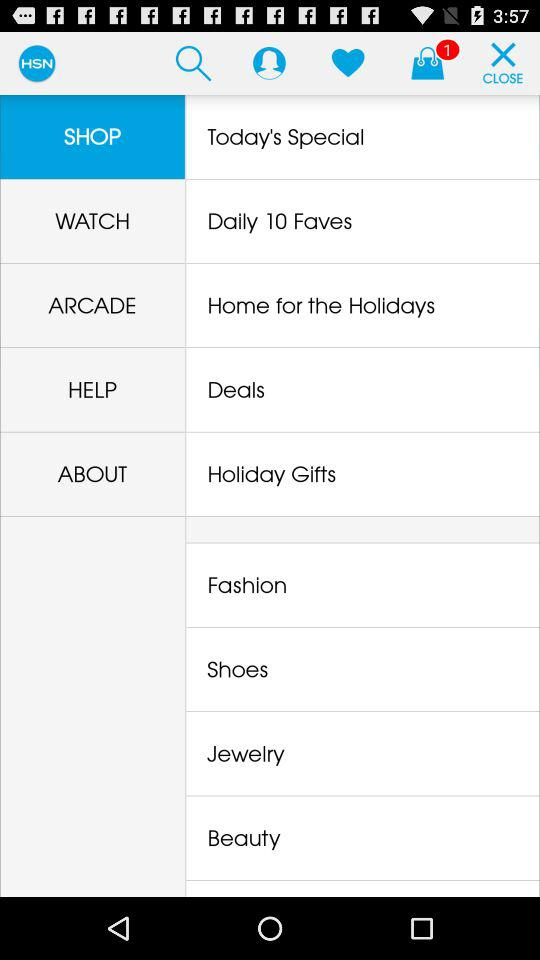How many items are in the bag? There is only 1 item in the bag. 